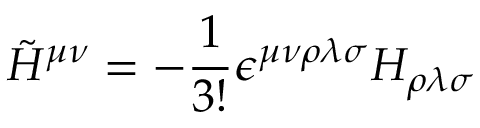<formula> <loc_0><loc_0><loc_500><loc_500>{ \tilde { H } } ^ { \mu \nu } = - \frac { 1 } 3 ! } \epsilon ^ { \mu \nu \rho \lambda \sigma } H _ { \rho \lambda \sigma }</formula> 